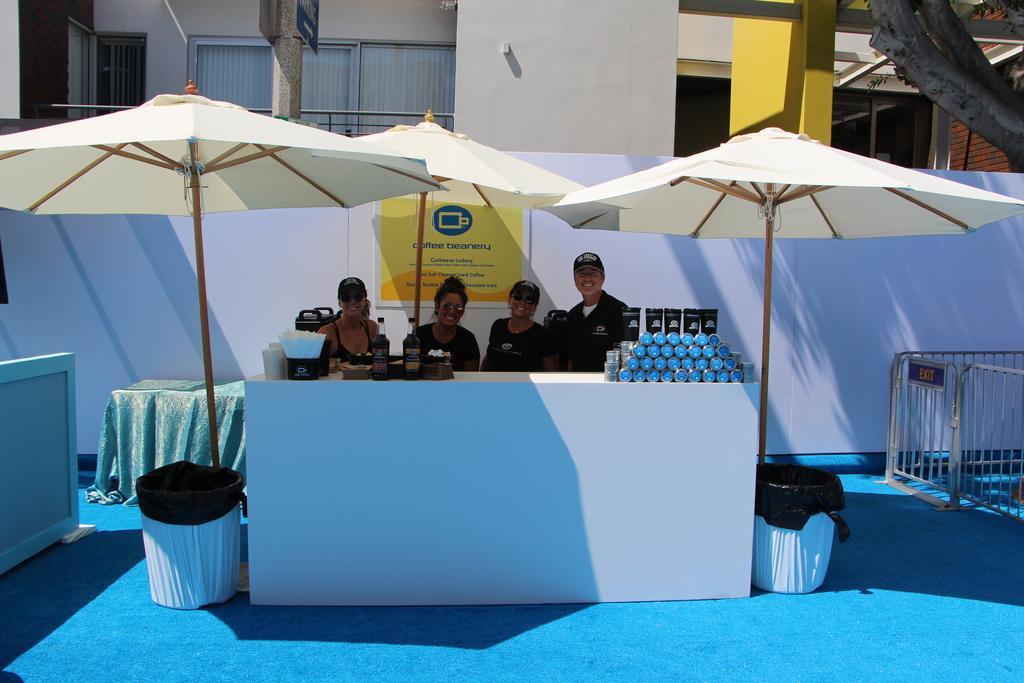Describe this image in one or two sentences. In this image i can see 3 woman and a man standing behind the desk, On the desk i can see few objects and few bottles few tissues and few other objects. In the background i can see the building, the pillar, a tree, few tents, and few windows. I can see 2 dustbins on the each side of the desk and the railing. 